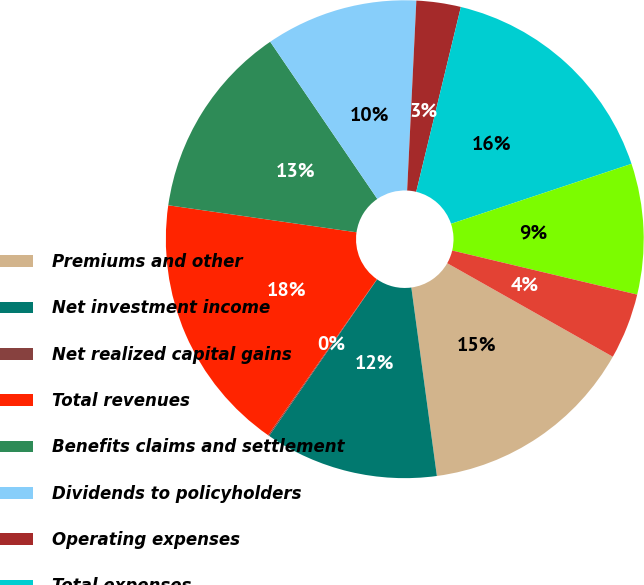<chart> <loc_0><loc_0><loc_500><loc_500><pie_chart><fcel>Premiums and other<fcel>Net investment income<fcel>Net realized capital gains<fcel>Total revenues<fcel>Benefits claims and settlement<fcel>Dividends to policyholders<fcel>Operating expenses<fcel>Total expenses<fcel>Closed Block revenues net of<fcel>Income taxes<nl><fcel>14.67%<fcel>11.75%<fcel>0.08%<fcel>17.58%<fcel>13.21%<fcel>10.29%<fcel>3.0%<fcel>16.12%<fcel>8.83%<fcel>4.46%<nl></chart> 